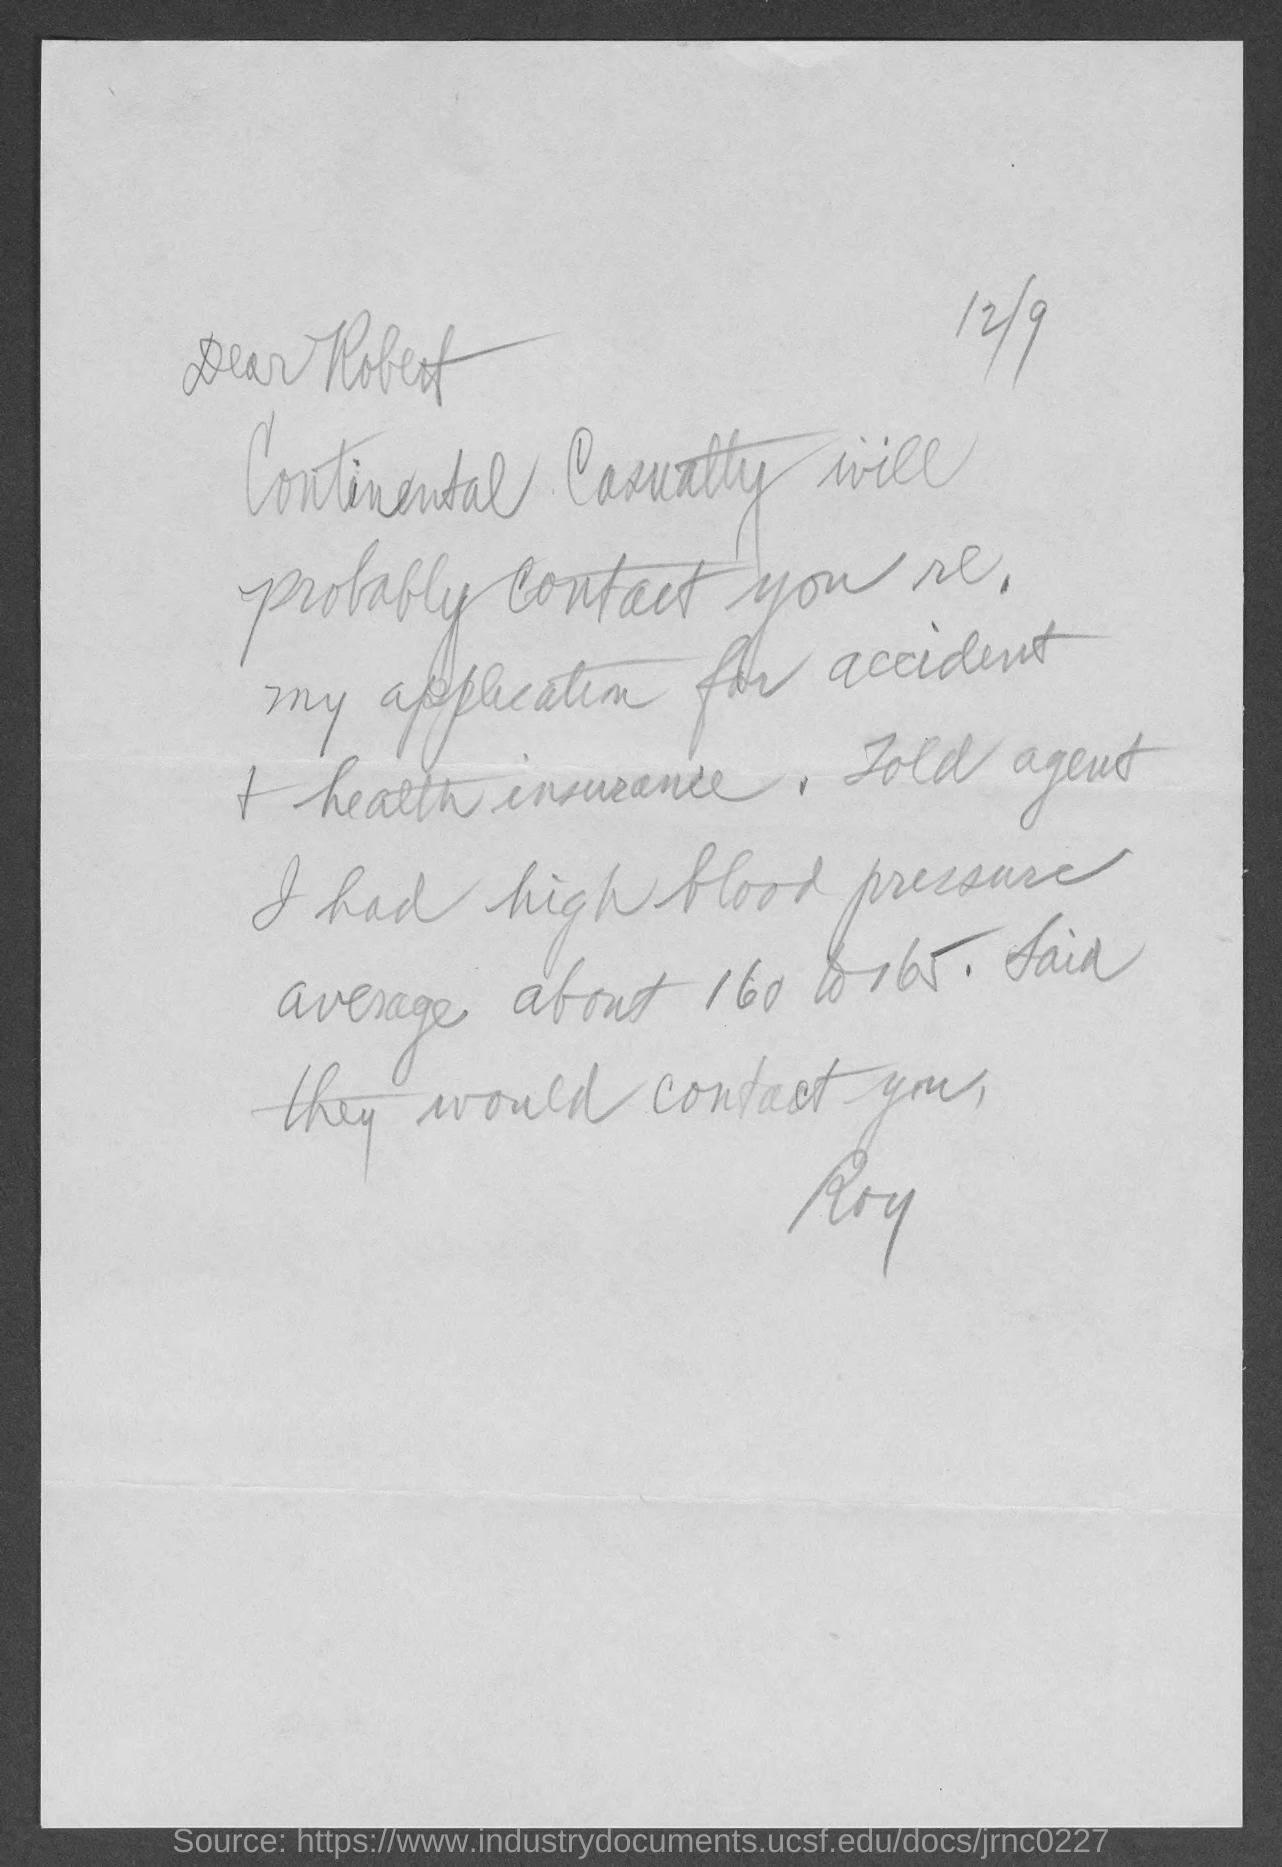Give some essential details in this illustration. The letter is dated December 9th. The sender of this letter is Roy. The letter is addressed to Robert. 